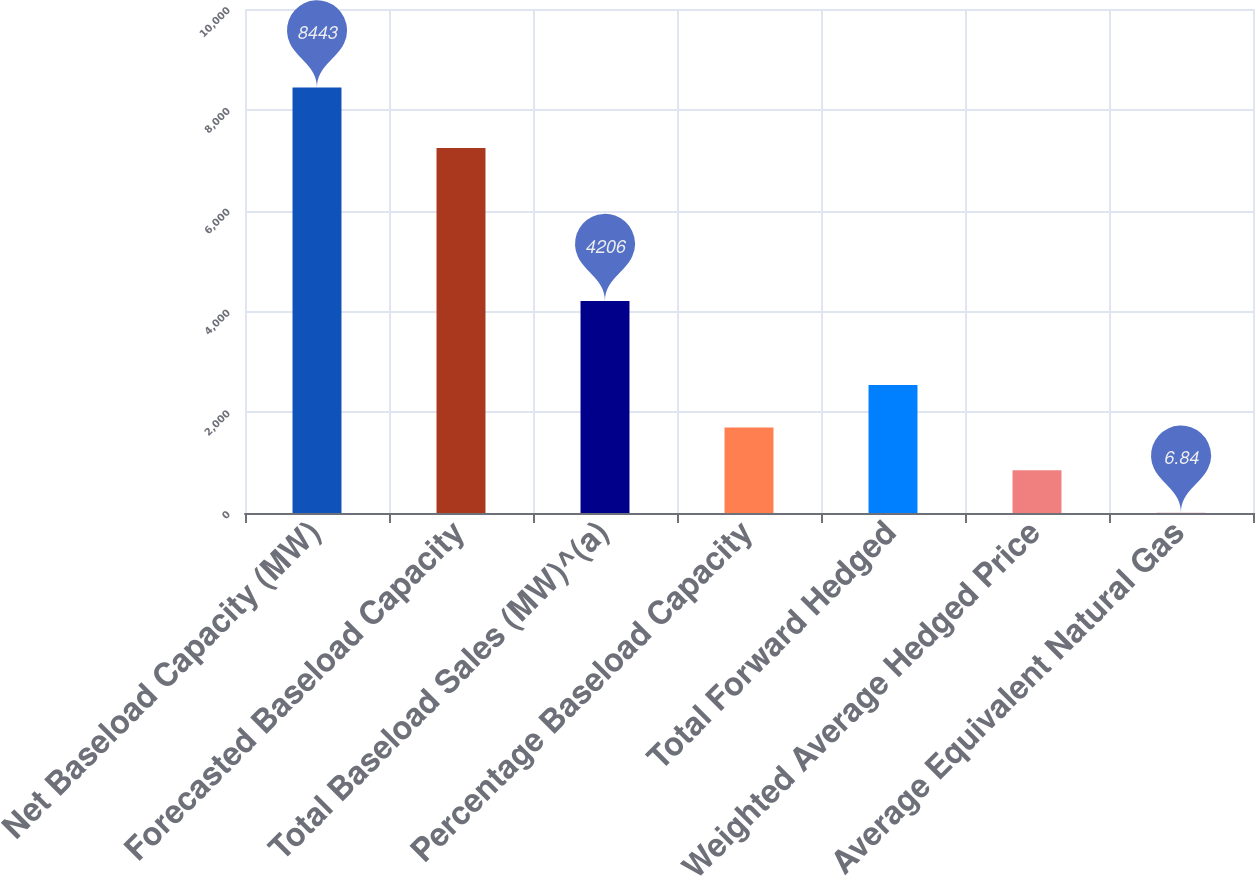<chart> <loc_0><loc_0><loc_500><loc_500><bar_chart><fcel>Net Baseload Capacity (MW)<fcel>Forecasted Baseload Capacity<fcel>Total Baseload Sales (MW)^(a)<fcel>Percentage Baseload Capacity<fcel>Total Forward Hedged<fcel>Weighted Average Hedged Price<fcel>Average Equivalent Natural Gas<nl><fcel>8443<fcel>7241<fcel>4206<fcel>1694.08<fcel>2537.7<fcel>850.46<fcel>6.84<nl></chart> 